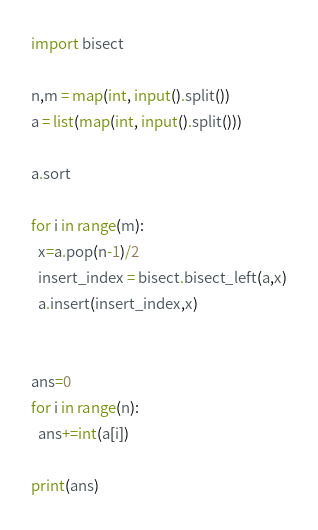<code> <loc_0><loc_0><loc_500><loc_500><_Python_>import bisect

n,m = map(int, input().split())
a = list(map(int, input().split()))

a.sort

for i in range(m):
  x=a.pop(n-1)/2
  insert_index = bisect.bisect_left(a,x)
  a.insert(insert_index,x)


ans=0
for i in range(n):
  ans+=int(a[i])
  
print(ans)</code> 